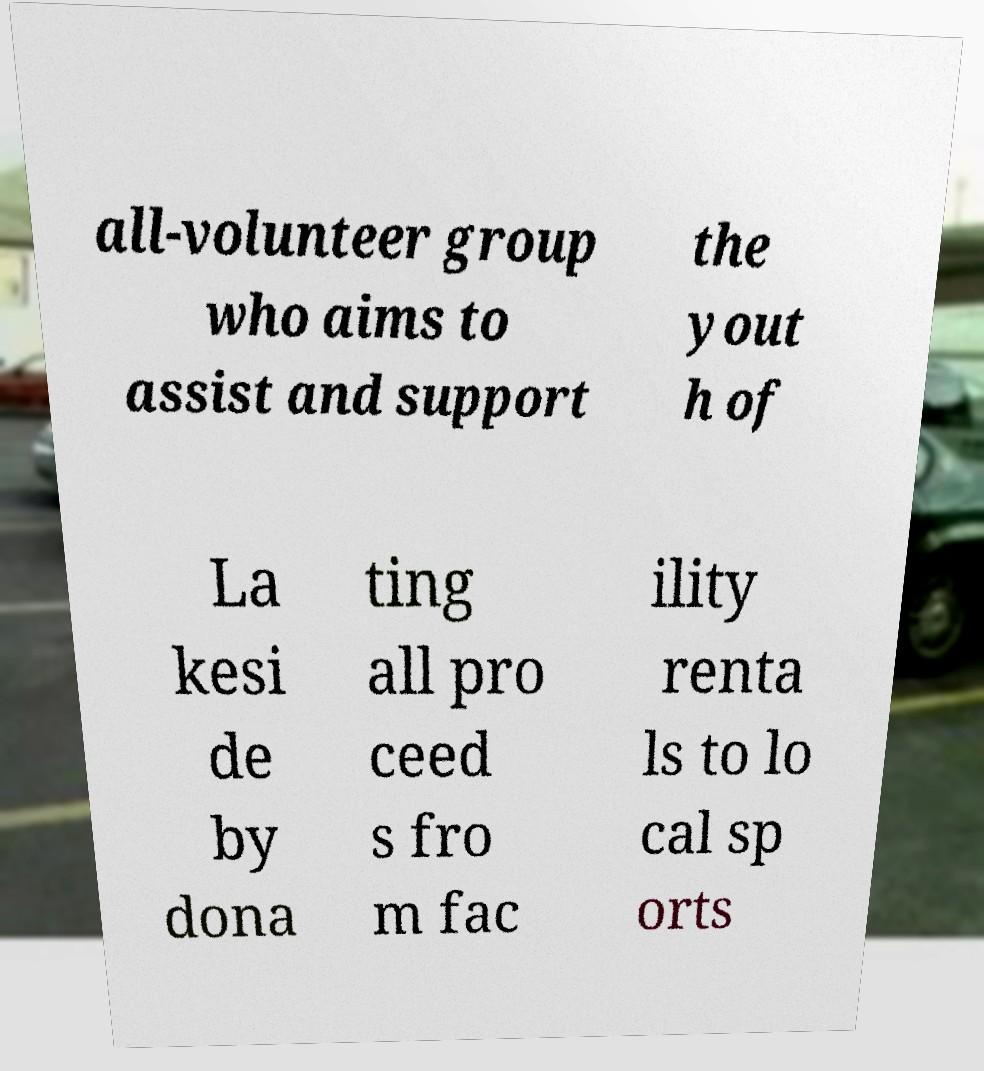Please read and relay the text visible in this image. What does it say? all-volunteer group who aims to assist and support the yout h of La kesi de by dona ting all pro ceed s fro m fac ility renta ls to lo cal sp orts 